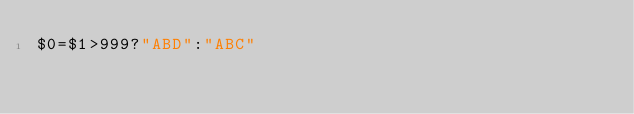Convert code to text. <code><loc_0><loc_0><loc_500><loc_500><_Awk_>$0=$1>999?"ABD":"ABC"</code> 